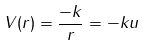<formula> <loc_0><loc_0><loc_500><loc_500>V ( r ) = \frac { - k } { r } = - k u</formula> 